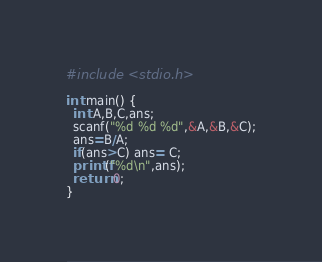<code> <loc_0><loc_0><loc_500><loc_500><_Awk_>#include <stdio.h>

int main() {
  int A,B,C,ans;
  scanf("%d %d %d",&A,&B,&C);
  ans=B/A;
  if(ans>C) ans= C;
  printf("%d\n",ans);
  return 0;
}</code> 